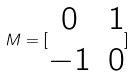<formula> <loc_0><loc_0><loc_500><loc_500>M = [ \begin{matrix} 0 & 1 \\ - 1 & 0 \end{matrix} ]</formula> 